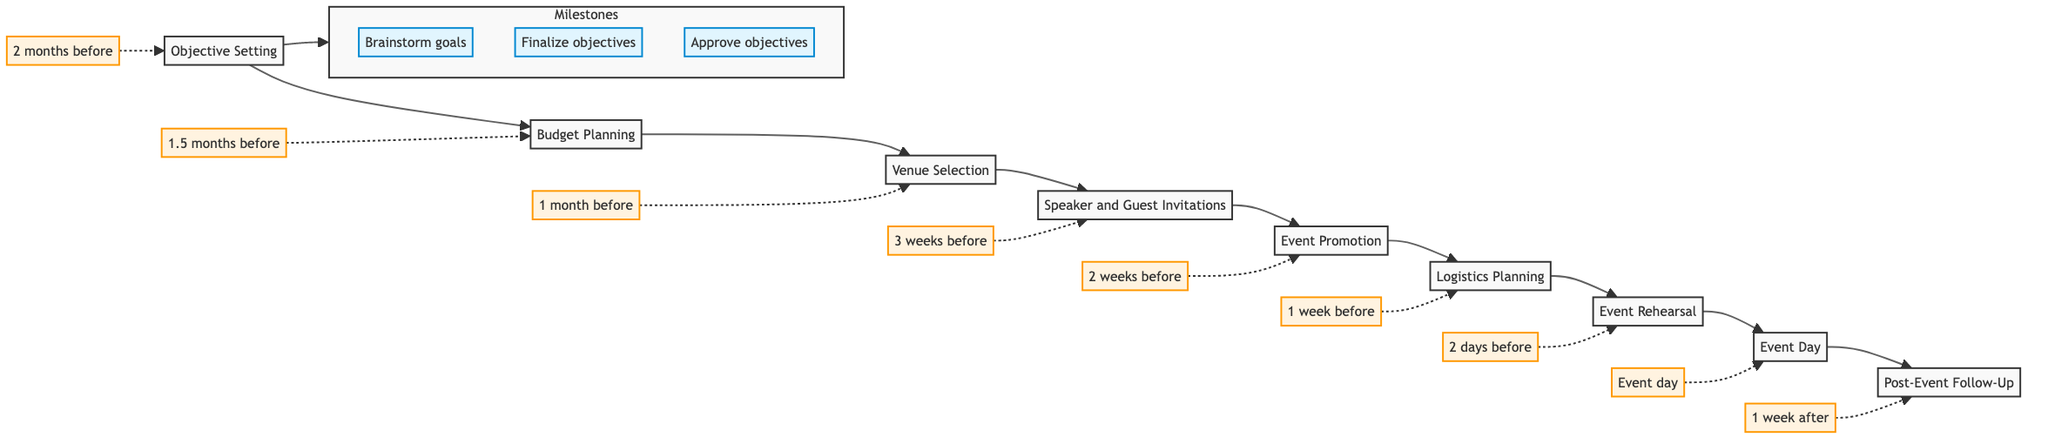What is the first step in the process? The first step is indicated by the leftmost node in the diagram, which is "Objective Setting."
Answer: Objective Setting How many milestones are there for "Objective Setting"? The milestones are listed directly under the "Objective Setting" node, which shows three milestones: "Brainstorm goals," "Finalize objectives," and "Approve objectives."
Answer: 3 What are the deadlines for "Event Promotion"? The deadline is indicated beside the "Event Promotion" node, which states it is due "2 weeks before event."
Answer: 2 weeks before Which step follows "Venue Selection"? The diagram shows a direct flow from "Venue Selection" to the next node, which is "Speaker and Guest Invitations."
Answer: Speaker and Guest Invitations What is the last step in the planning process? The last step is found at the rightmost node in the flowchart. It is "Post-Event Follow-Up."
Answer: Post-Event Follow-Up Which milestone needs to be completed just before "Event Day"? Looking at the flow, just before the "Event Day," the preceding step is "Event Rehearsal," and its last milestone is "Finalize run of show."
Answer: Finalize run of show What is the relationship between "Logistics Planning" and "Event Rehearsal"? "Logistics Planning" leads directly to "Event Rehearsal," indicating that completing logistics is essential before rehearsing for the event.
Answer: Direct progression When should "Budget Planning" be completed? The timeline indicated next to "Budget Planning" shows it must be finalized "1.5 months before event."
Answer: 1.5 months before What step occurs at the same time as the "Event Day"? The deadline listed next to "Event Day" indicates that actions such as setup and hosting occur simultaneously on that same day, which is emphasized in the node itself.
Answer: Event day 